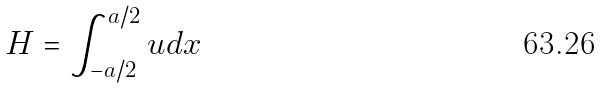Convert formula to latex. <formula><loc_0><loc_0><loc_500><loc_500>H = \int _ { - a / 2 } ^ { a / 2 } u d x</formula> 